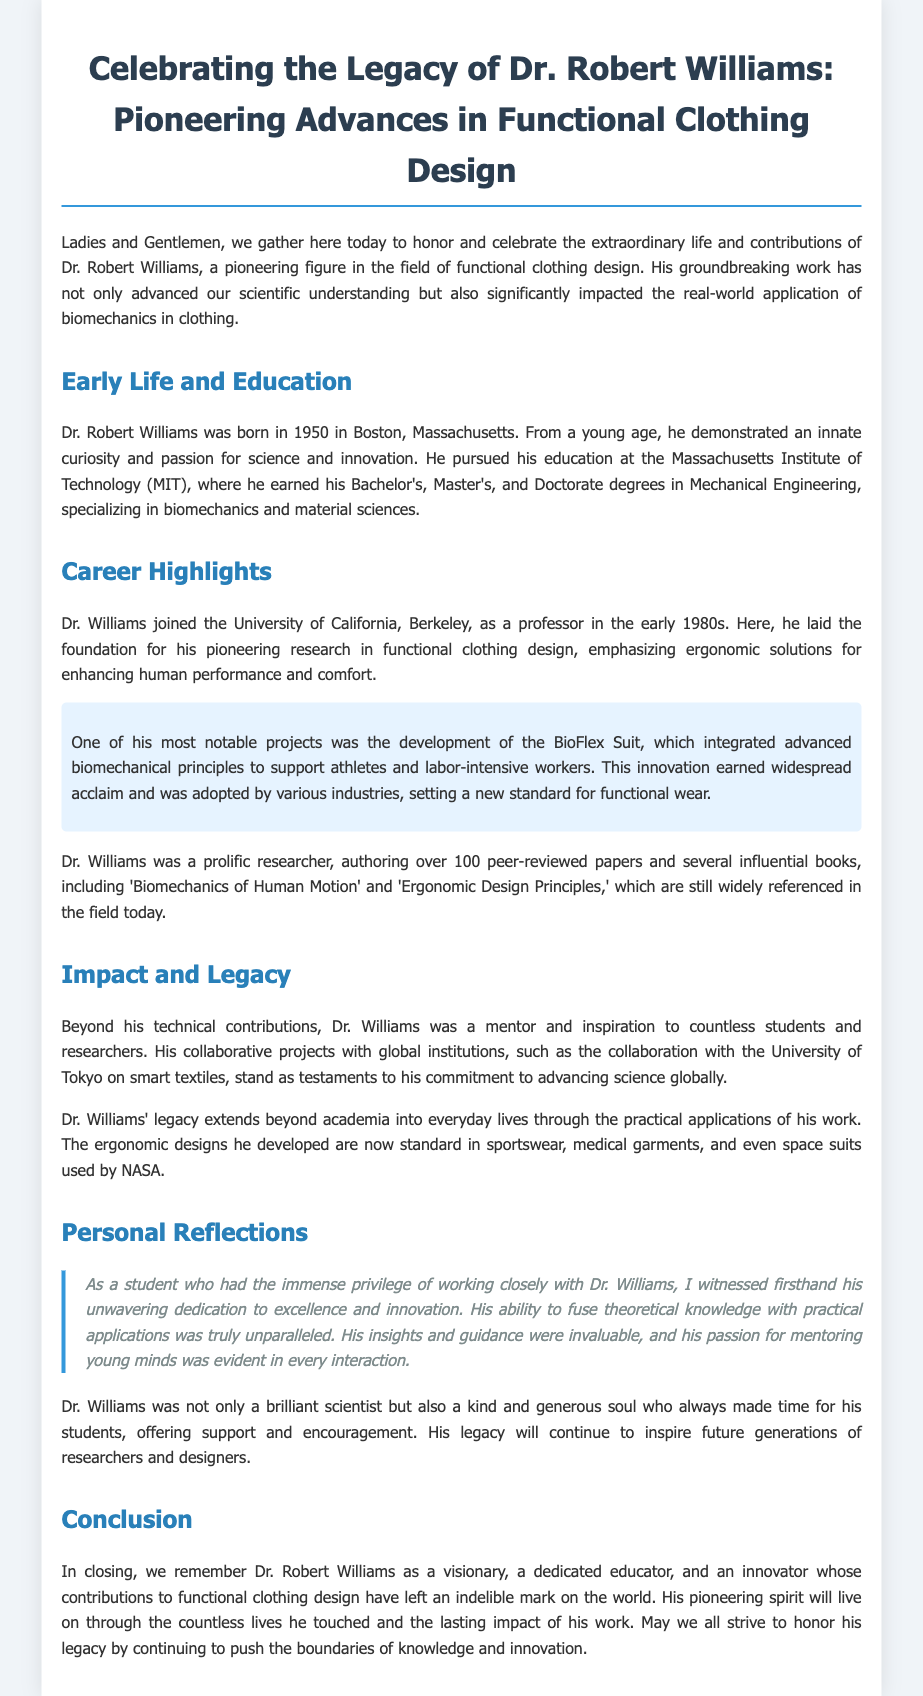What year was Dr. Robert Williams born? The document states that Dr. Robert Williams was born in 1950.
Answer: 1950 What university did Dr. Williams attend for his degrees? The document mentions that he earned his degrees at the Massachusetts Institute of Technology (MIT).
Answer: MIT What innovative project is highlighted in Dr. Williams' career? The document refers to the development of the BioFlex Suit as one of his notable projects.
Answer: BioFlex Suit How many peer-reviewed papers did Dr. Williams author? The document indicates that Dr. Williams authored over 100 peer-reviewed papers.
Answer: 100 What was Dr. Williams' focus in his research? The document highlights that he emphasized ergonomic solutions for enhancing human performance and comfort.
Answer: Ergonomic solutions What was Dr. Williams' role at the University of California, Berkeley? The document states that he joined the university as a professor.
Answer: Professor What legacy did Dr. Williams leave in everyday life? The document explains that his ergonomic designs became standard in various types of clothing, including sportswear and medical garments.
Answer: Ergonomic designs What characteristic did Dr. Williams display as a mentor? The document emphasizes that he was kind and generous, always making time for his students.
Answer: Kind and generous What is a key theme of the conclusion in the eulogy? The document concludes that Dr. Williams was a visionary and innovator whose contributions have left a lasting impact.
Answer: Visionary and innovator 